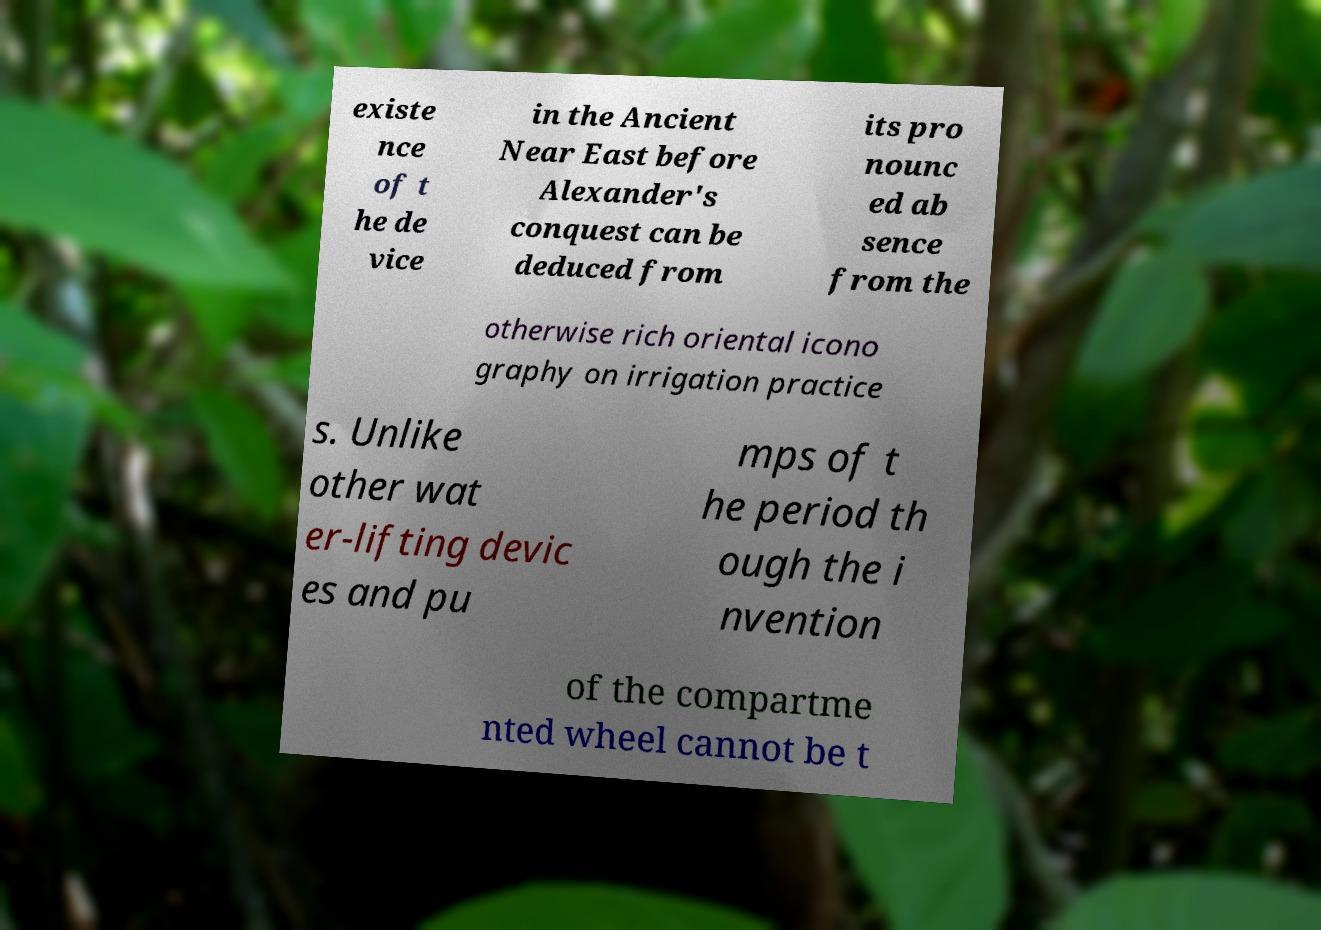Please identify and transcribe the text found in this image. existe nce of t he de vice in the Ancient Near East before Alexander's conquest can be deduced from its pro nounc ed ab sence from the otherwise rich oriental icono graphy on irrigation practice s. Unlike other wat er-lifting devic es and pu mps of t he period th ough the i nvention of the compartme nted wheel cannot be t 